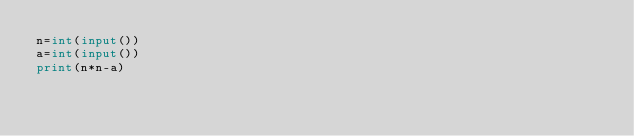Convert code to text. <code><loc_0><loc_0><loc_500><loc_500><_Python_>n=int(input())
a=int(input())
print(n*n-a)</code> 